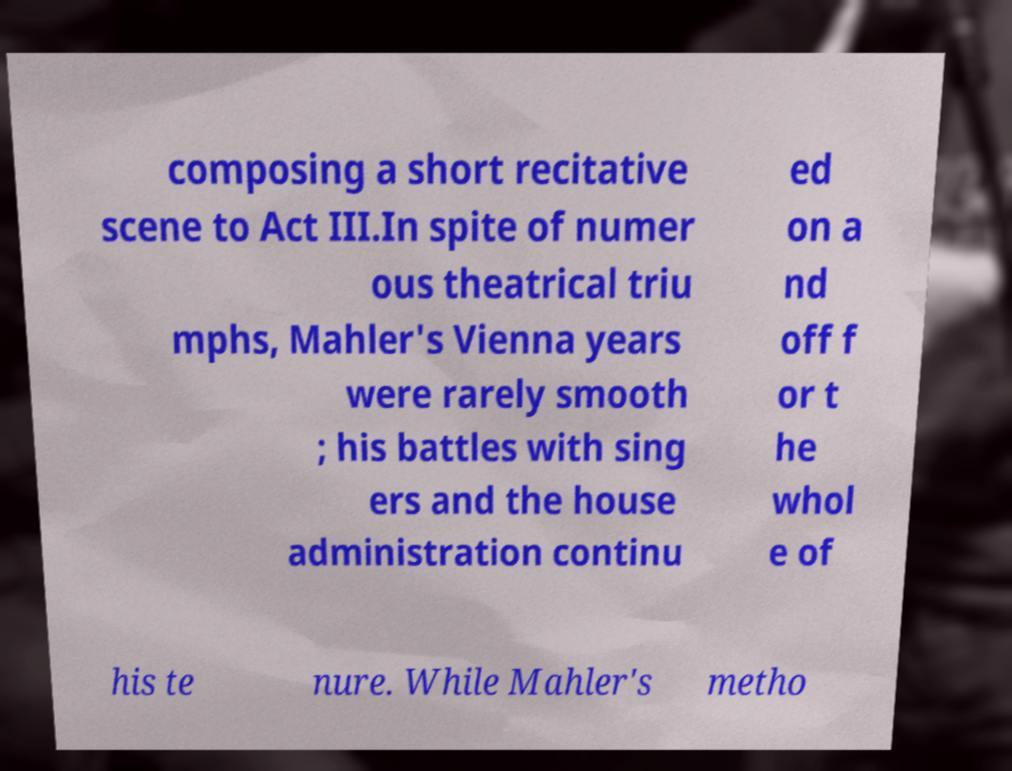There's text embedded in this image that I need extracted. Can you transcribe it verbatim? composing a short recitative scene to Act III.In spite of numer ous theatrical triu mphs, Mahler's Vienna years were rarely smooth ; his battles with sing ers and the house administration continu ed on a nd off f or t he whol e of his te nure. While Mahler's metho 